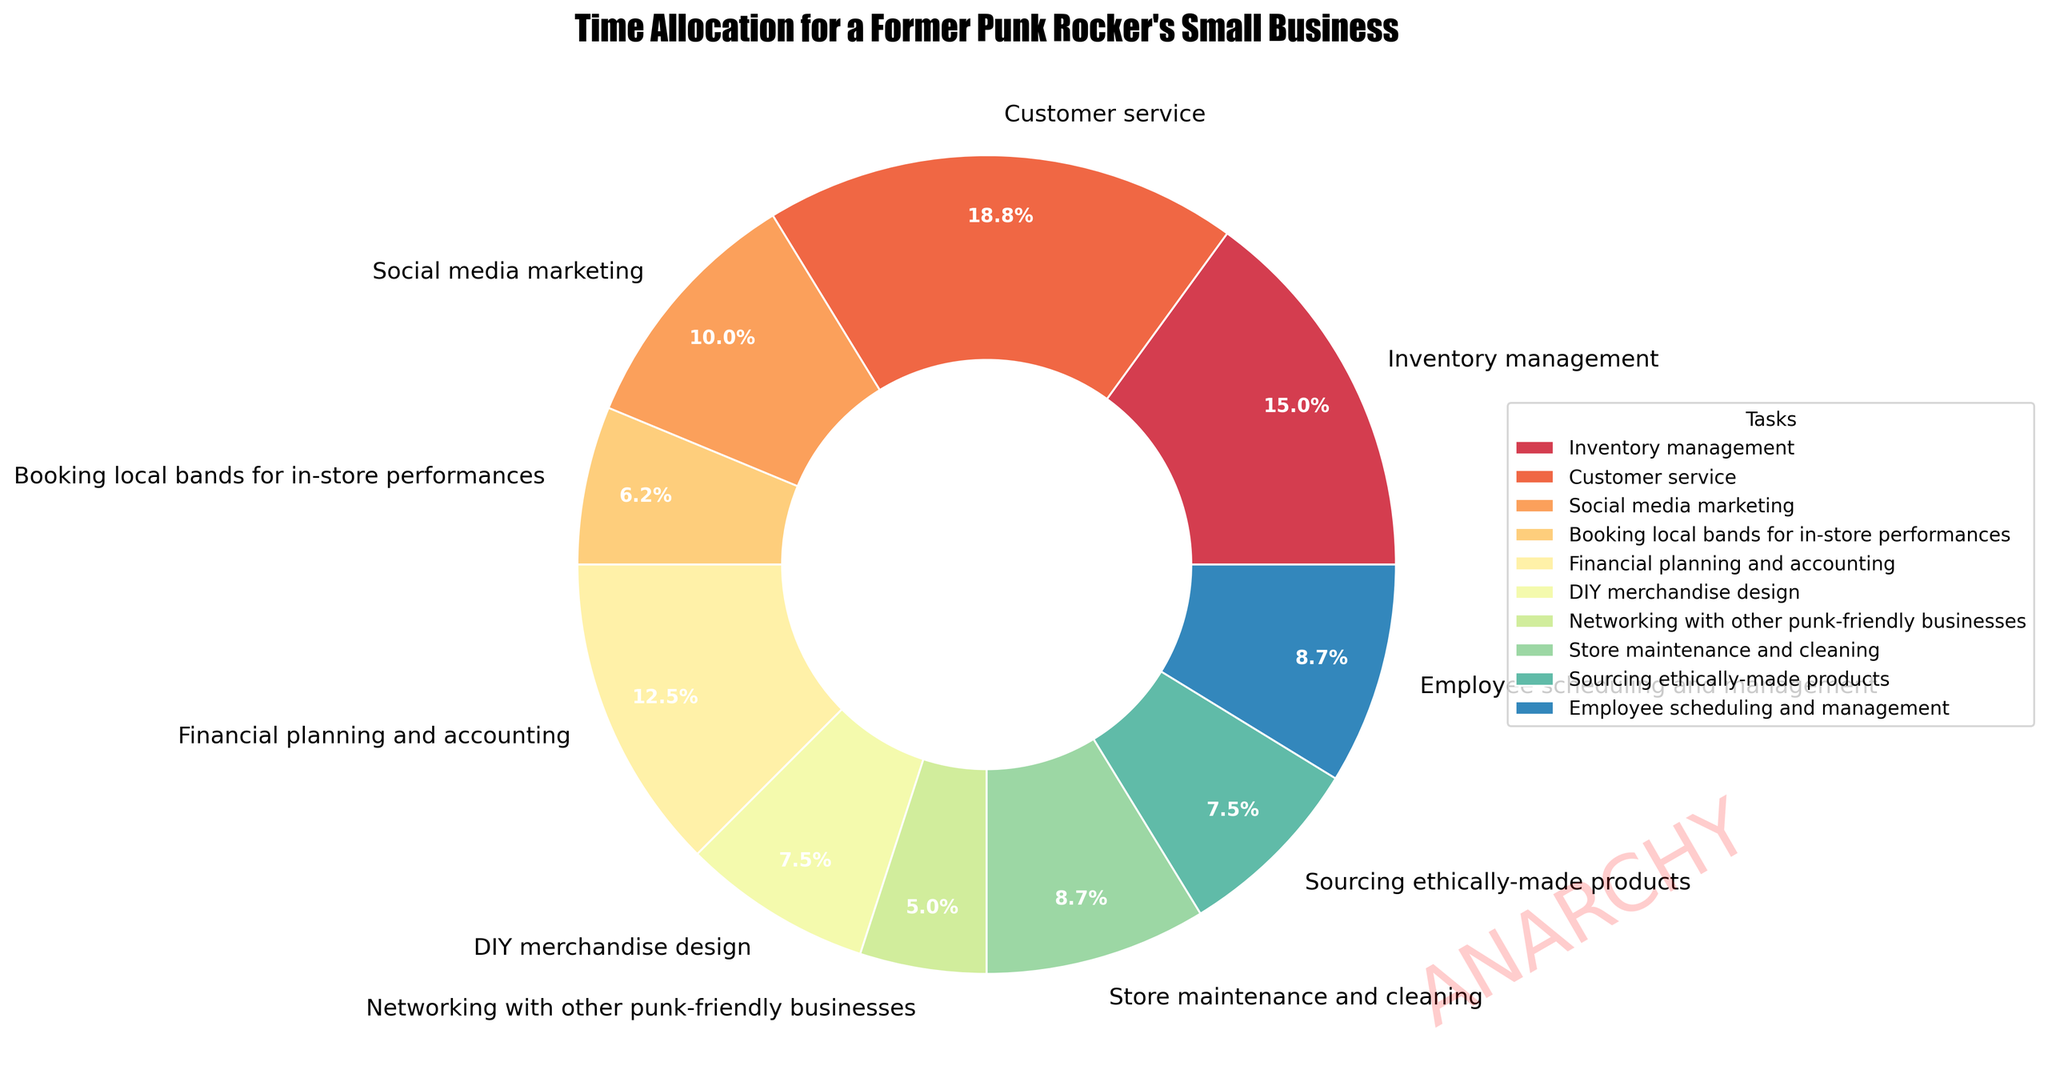Which task takes up the most hours per week? Refer to the pie chart and look for the largest slice. "Customer service" is the largest section.
Answer: Customer service Which task requires more hours: DIY merchandise design or store maintenance and cleaning? Compare the sizes of the slices for "DIY merchandise design" and "store maintenance and cleaning." "Store maintenance and cleaning" has a larger slice.
Answer: Store maintenance and cleaning What is the combined percentage of time spent on social media marketing and booking local bands for in-store performances? Find the individual percentages for "social media marketing" and "booking local bands for in-store performances" in the pie chart and add them together. "Social media marketing" is 8% and "booking local bands for in-store performances" is 5%.
Answer: 13% Which task has a smaller share: sourcing ethically-made products or employee scheduling and management? Compare the slices for "sourcing ethically-made products" and "employee scheduling and management." "Sourcing ethically-made products" has a smaller slice.
Answer: Sourcing ethically-made products How does the time spent on financial planning and accounting compare to the time spent on inventory management? Compare the slices for "financial planning and accounting" and "inventory management." "Financial planning and accounting" is slightly smaller than "inventory management."
Answer: Less Is there a task that takes exactly 5 hours per week? Look at the pie chart slices for the task labels and find the one with 5 hours. "Booking local bands for in-store performances" has 5 hours.
Answer: Booking local bands for in-store performances What is the total time spent on networking with other punk-friendly businesses and employee scheduling and management? Add the hours of "networking with other punk-friendly businesses" (4 hours) and "employee scheduling and management" (7 hours).
Answer: 11 hours What percentage of the time is spent on tasks related to customer interactions (customer service and social media marketing)? Add the percentages of "customer service" (15%) and "social media marketing" (8%).
Answer: 23% Which two tasks combined make up more time than customer service alone? Look for two tasks whose percentages sum up to more than "customer service" (15%). "Inventory management" (12%) and "financial planning and accounting" (10%) add up to 22%, which is more than customer service.
Answer: Inventory management and financial planning and accounting What is the least time-consuming task? Find the smallest slice in the pie chart. "Networking with other punk-friendly businesses" has the smallest section.
Answer: Networking with other punk-friendly businesses 